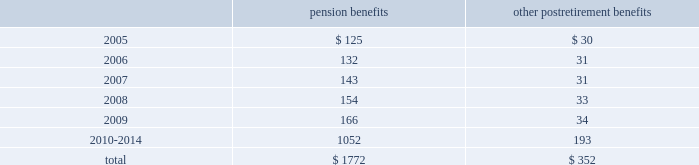Notes to consolidated financial statements ( continued ) 17 .
Pension plans and postretirement health care and life insurance benefit plans ( continued ) benefit payments the table sets forth amounts of benefits expected to be paid over the next ten years from the company 2019s pension and postretirement plans as of december 31 , 2004: .
18 .
Stock compensation plans on may 18 , 2000 , the shareholders of the hartford approved the hartford incentive stock plan ( the 201c2000 plan 201d ) , which replaced the hartford 1995 incentive stock plan ( the 201c1995 plan 201d ) .
The terms of the 2000 plan were substantially similar to the terms of the 1995 plan except that the 1995 plan had an annual award limit and a higher maximum award limit .
Under the 2000 plan , awards may be granted in the form of non-qualified or incentive stock options qualifying under section 422a of the internal revenue code , performance shares or restricted stock , or any combination of the foregoing .
In addition , stock appreciation rights may be granted in connection with all or part of any stock options granted under the 2000 plan .
In december 2004 , the 2000 plan was amended to allow for grants of restricted stock units effective as of january 1 , 2005 .
The aggregate number of shares of stock , which may be awarded , is subject to a maximum limit of 17211837 shares applicable to all awards for the ten-year duration of the 2000 plan .
All options granted have an exercise price equal to the market price of the company 2019s common stock on the date of grant , and an option 2019s maximum term is ten years and two days .
Certain options become exercisable over a three year period commencing one year from the date of grant , while certain other options become exercisable upon the attainment of specified market price appreciation of the company 2019s common shares .
For any year , no individual employee may receive an award of options for more than 1000000 shares .
As of december 31 , 2004 , the hartford had not issued any incentive stock options under the 2000 plan .
Performance awards of common stock granted under the 2000 plan become payable upon the attainment of specific performance goals achieved over a period of not less than one nor more than five years , and the restricted stock granted is subject to a restriction period .
On a cumulative basis , no more than 20% ( 20 % ) of the aggregate number of shares which may be awarded under the 2000 plan are available for performance shares and restricted stock awards .
Also , the maximum award of performance shares for any individual employee in any year is 200000 shares .
In 2004 , 2003 and 2002 , the company granted shares of common stock of 315452 , 333712 and 40852 with weighted average prices of $ 64.93 , $ 38.13 and $ 62.28 , respectively , related to performance share and restricted stock awards .
In 1996 , the company established the hartford employee stock purchase plan ( 201cespp 201d ) .
Under this plan , eligible employees of the hartford may purchase common stock of the company at a 15% ( 15 % ) discount from the lower of the closing market price at the beginning or end of the quarterly offering period .
The company may sell up to 5400000 shares of stock to eligible employees under the espp .
In 2004 , 2003 and 2002 , 345262 , 443467 and 408304 shares were sold , respectively .
The per share weighted average fair value of the discount under the espp was $ 9.31 , $ 11.96 , and $ 11.70 in 2004 , 2003 and 2002 , respectively .
Additionally , during 1997 , the hartford established employee stock purchase plans for certain employees of the company 2019s international subsidiaries .
Under these plans , participants may purchase common stock of the hartford at a fixed price at the end of a three-year period .
The activity under these programs is not material. .
What is the expected payment for all benefits in 2007? 
Computations: (143 + 31)
Answer: 174.0. Notes to consolidated financial statements ( continued ) 17 .
Pension plans and postretirement health care and life insurance benefit plans ( continued ) benefit payments the table sets forth amounts of benefits expected to be paid over the next ten years from the company 2019s pension and postretirement plans as of december 31 , 2004: .
18 .
Stock compensation plans on may 18 , 2000 , the shareholders of the hartford approved the hartford incentive stock plan ( the 201c2000 plan 201d ) , which replaced the hartford 1995 incentive stock plan ( the 201c1995 plan 201d ) .
The terms of the 2000 plan were substantially similar to the terms of the 1995 plan except that the 1995 plan had an annual award limit and a higher maximum award limit .
Under the 2000 plan , awards may be granted in the form of non-qualified or incentive stock options qualifying under section 422a of the internal revenue code , performance shares or restricted stock , or any combination of the foregoing .
In addition , stock appreciation rights may be granted in connection with all or part of any stock options granted under the 2000 plan .
In december 2004 , the 2000 plan was amended to allow for grants of restricted stock units effective as of january 1 , 2005 .
The aggregate number of shares of stock , which may be awarded , is subject to a maximum limit of 17211837 shares applicable to all awards for the ten-year duration of the 2000 plan .
All options granted have an exercise price equal to the market price of the company 2019s common stock on the date of grant , and an option 2019s maximum term is ten years and two days .
Certain options become exercisable over a three year period commencing one year from the date of grant , while certain other options become exercisable upon the attainment of specified market price appreciation of the company 2019s common shares .
For any year , no individual employee may receive an award of options for more than 1000000 shares .
As of december 31 , 2004 , the hartford had not issued any incentive stock options under the 2000 plan .
Performance awards of common stock granted under the 2000 plan become payable upon the attainment of specific performance goals achieved over a period of not less than one nor more than five years , and the restricted stock granted is subject to a restriction period .
On a cumulative basis , no more than 20% ( 20 % ) of the aggregate number of shares which may be awarded under the 2000 plan are available for performance shares and restricted stock awards .
Also , the maximum award of performance shares for any individual employee in any year is 200000 shares .
In 2004 , 2003 and 2002 , the company granted shares of common stock of 315452 , 333712 and 40852 with weighted average prices of $ 64.93 , $ 38.13 and $ 62.28 , respectively , related to performance share and restricted stock awards .
In 1996 , the company established the hartford employee stock purchase plan ( 201cespp 201d ) .
Under this plan , eligible employees of the hartford may purchase common stock of the company at a 15% ( 15 % ) discount from the lower of the closing market price at the beginning or end of the quarterly offering period .
The company may sell up to 5400000 shares of stock to eligible employees under the espp .
In 2004 , 2003 and 2002 , 345262 , 443467 and 408304 shares were sold , respectively .
The per share weighted average fair value of the discount under the espp was $ 9.31 , $ 11.96 , and $ 11.70 in 2004 , 2003 and 2002 , respectively .
Additionally , during 1997 , the hartford established employee stock purchase plans for certain employees of the company 2019s international subsidiaries .
Under these plans , participants may purchase common stock of the hartford at a fixed price at the end of a three-year period .
The activity under these programs is not material. .
As december 2004 what was the percent of the company 2019s total pension and postretirement plans that was due in 2007? 
Computations: ((143 + 31) / (1772 + 352))
Answer: 0.08192. 